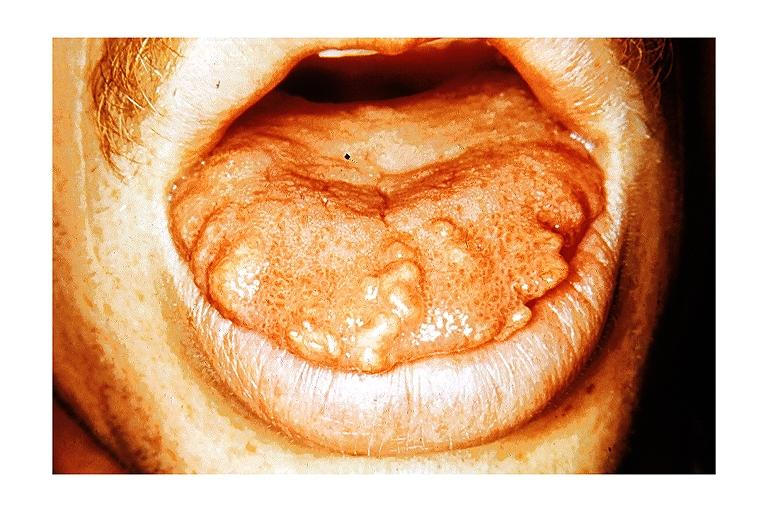s there present?
Answer the question using a single word or phrase. No 